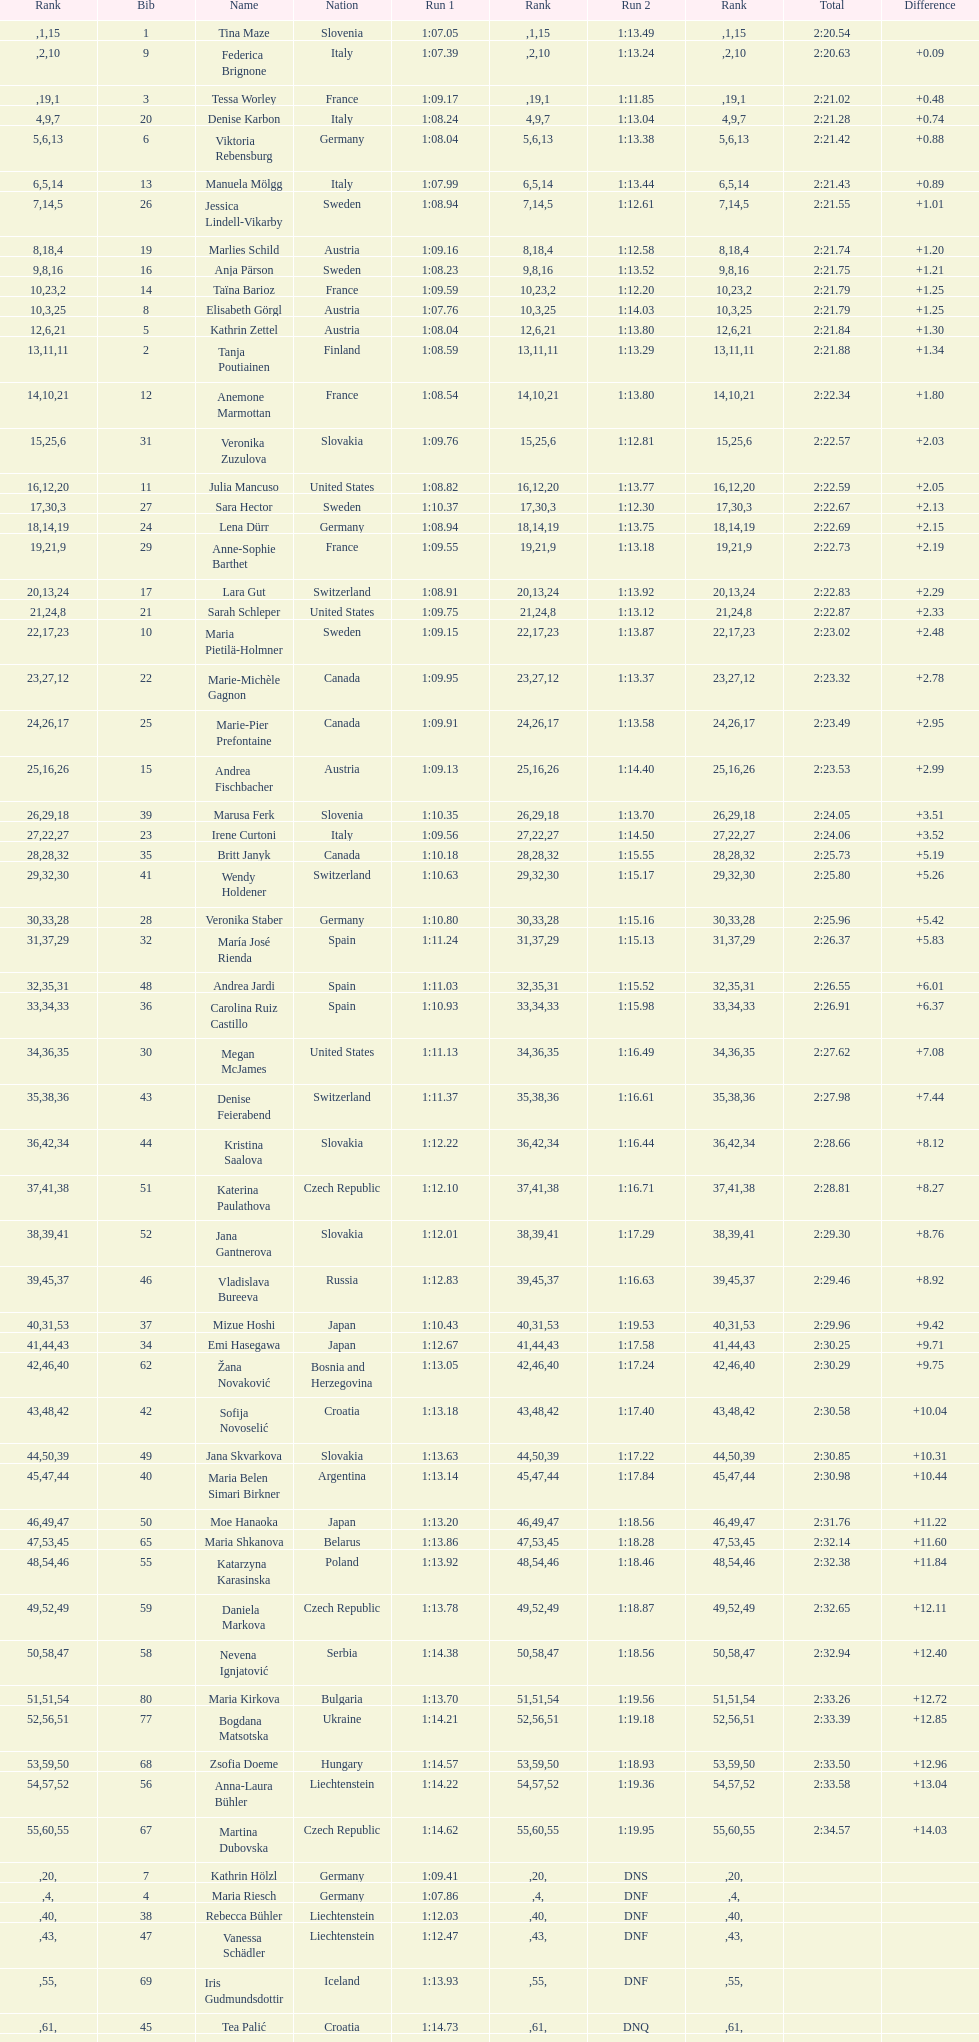How many italians ended up in the top ten positions? 3. 